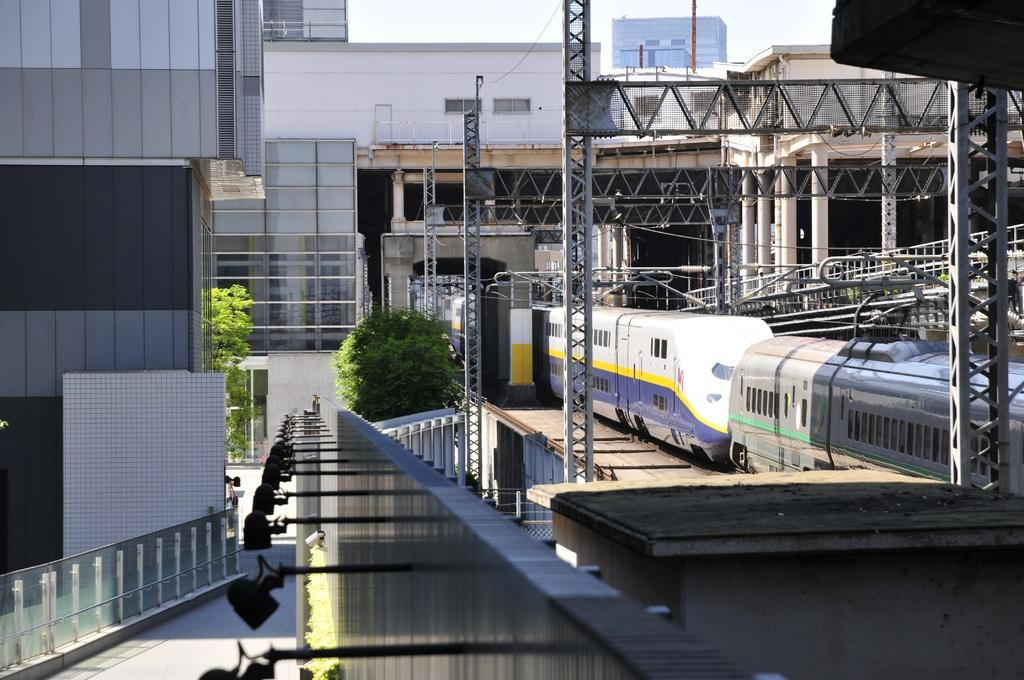What is the main subject of the image? The main subject of the image is trains on a track. What can be seen in the background of the image? In the background of the image, there are poles, buildings, and trees. Can you describe the left side of the image? On the left side of the image, there is a building, a path, and lights. What lesson is being taught in the image? There is no lesson being taught in the image; it depicts trains on a track and other elements in the background and on the left side. 